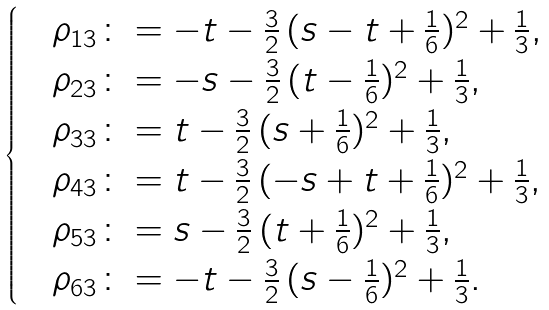Convert formula to latex. <formula><loc_0><loc_0><loc_500><loc_500>\begin{cases} & \rho _ { 1 3 } \colon = - t - \frac { 3 } { 2 } \, ( s - t + \frac { 1 } { 6 } ) ^ { 2 } + \frac { 1 } { 3 } , \\ & \rho _ { 2 3 } \colon = - s - \frac { 3 } { 2 } \, ( t - \frac { 1 } { 6 } ) ^ { 2 } + \frac { 1 } { 3 } , \\ & \rho _ { 3 3 } \colon = t - \frac { 3 } { 2 } \, ( s + \frac { 1 } { 6 } ) ^ { 2 } + \frac { 1 } { 3 } , \\ & \rho _ { 4 3 } \colon = t - \frac { 3 } { 2 } \, ( - s + t + \frac { 1 } { 6 } ) ^ { 2 } + \frac { 1 } { 3 } , \\ & \rho _ { 5 3 } \colon = s - \frac { 3 } { 2 } \, ( t + \frac { 1 } { 6 } ) ^ { 2 } + \frac { 1 } { 3 } , \\ & \rho _ { 6 3 } \colon = - t - \frac { 3 } { 2 } \, ( s - \frac { 1 } { 6 } ) ^ { 2 } + \frac { 1 } { 3 } . \end{cases}</formula> 